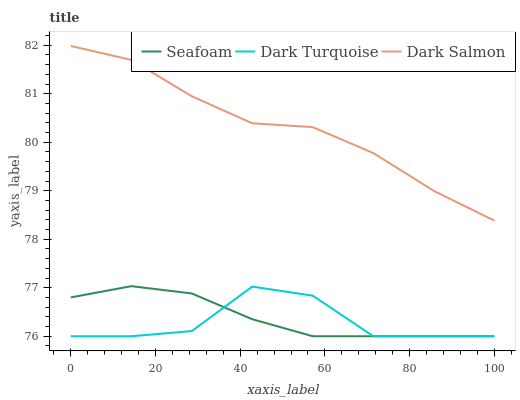Does Dark Turquoise have the minimum area under the curve?
Answer yes or no. Yes. Does Dark Salmon have the maximum area under the curve?
Answer yes or no. Yes. Does Seafoam have the minimum area under the curve?
Answer yes or no. No. Does Seafoam have the maximum area under the curve?
Answer yes or no. No. Is Seafoam the smoothest?
Answer yes or no. Yes. Is Dark Turquoise the roughest?
Answer yes or no. Yes. Is Dark Salmon the smoothest?
Answer yes or no. No. Is Dark Salmon the roughest?
Answer yes or no. No. Does Dark Turquoise have the lowest value?
Answer yes or no. Yes. Does Dark Salmon have the lowest value?
Answer yes or no. No. Does Dark Salmon have the highest value?
Answer yes or no. Yes. Does Seafoam have the highest value?
Answer yes or no. No. Is Seafoam less than Dark Salmon?
Answer yes or no. Yes. Is Dark Salmon greater than Seafoam?
Answer yes or no. Yes. Does Seafoam intersect Dark Turquoise?
Answer yes or no. Yes. Is Seafoam less than Dark Turquoise?
Answer yes or no. No. Is Seafoam greater than Dark Turquoise?
Answer yes or no. No. Does Seafoam intersect Dark Salmon?
Answer yes or no. No. 